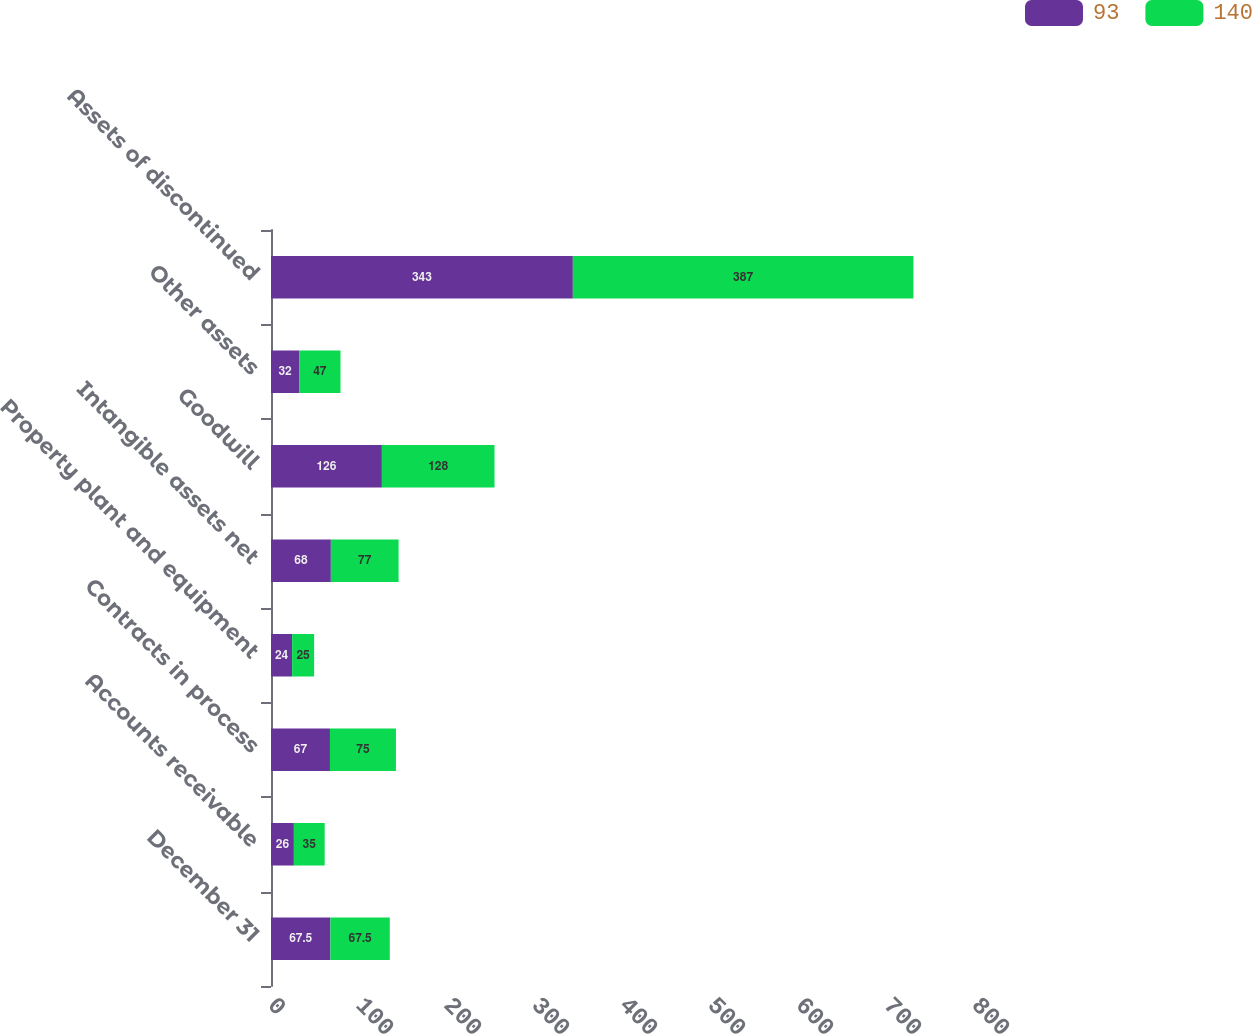Convert chart to OTSL. <chart><loc_0><loc_0><loc_500><loc_500><stacked_bar_chart><ecel><fcel>December 31<fcel>Accounts receivable<fcel>Contracts in process<fcel>Property plant and equipment<fcel>Intangible assets net<fcel>Goodwill<fcel>Other assets<fcel>Assets of discontinued<nl><fcel>93<fcel>67.5<fcel>26<fcel>67<fcel>24<fcel>68<fcel>126<fcel>32<fcel>343<nl><fcel>140<fcel>67.5<fcel>35<fcel>75<fcel>25<fcel>77<fcel>128<fcel>47<fcel>387<nl></chart> 